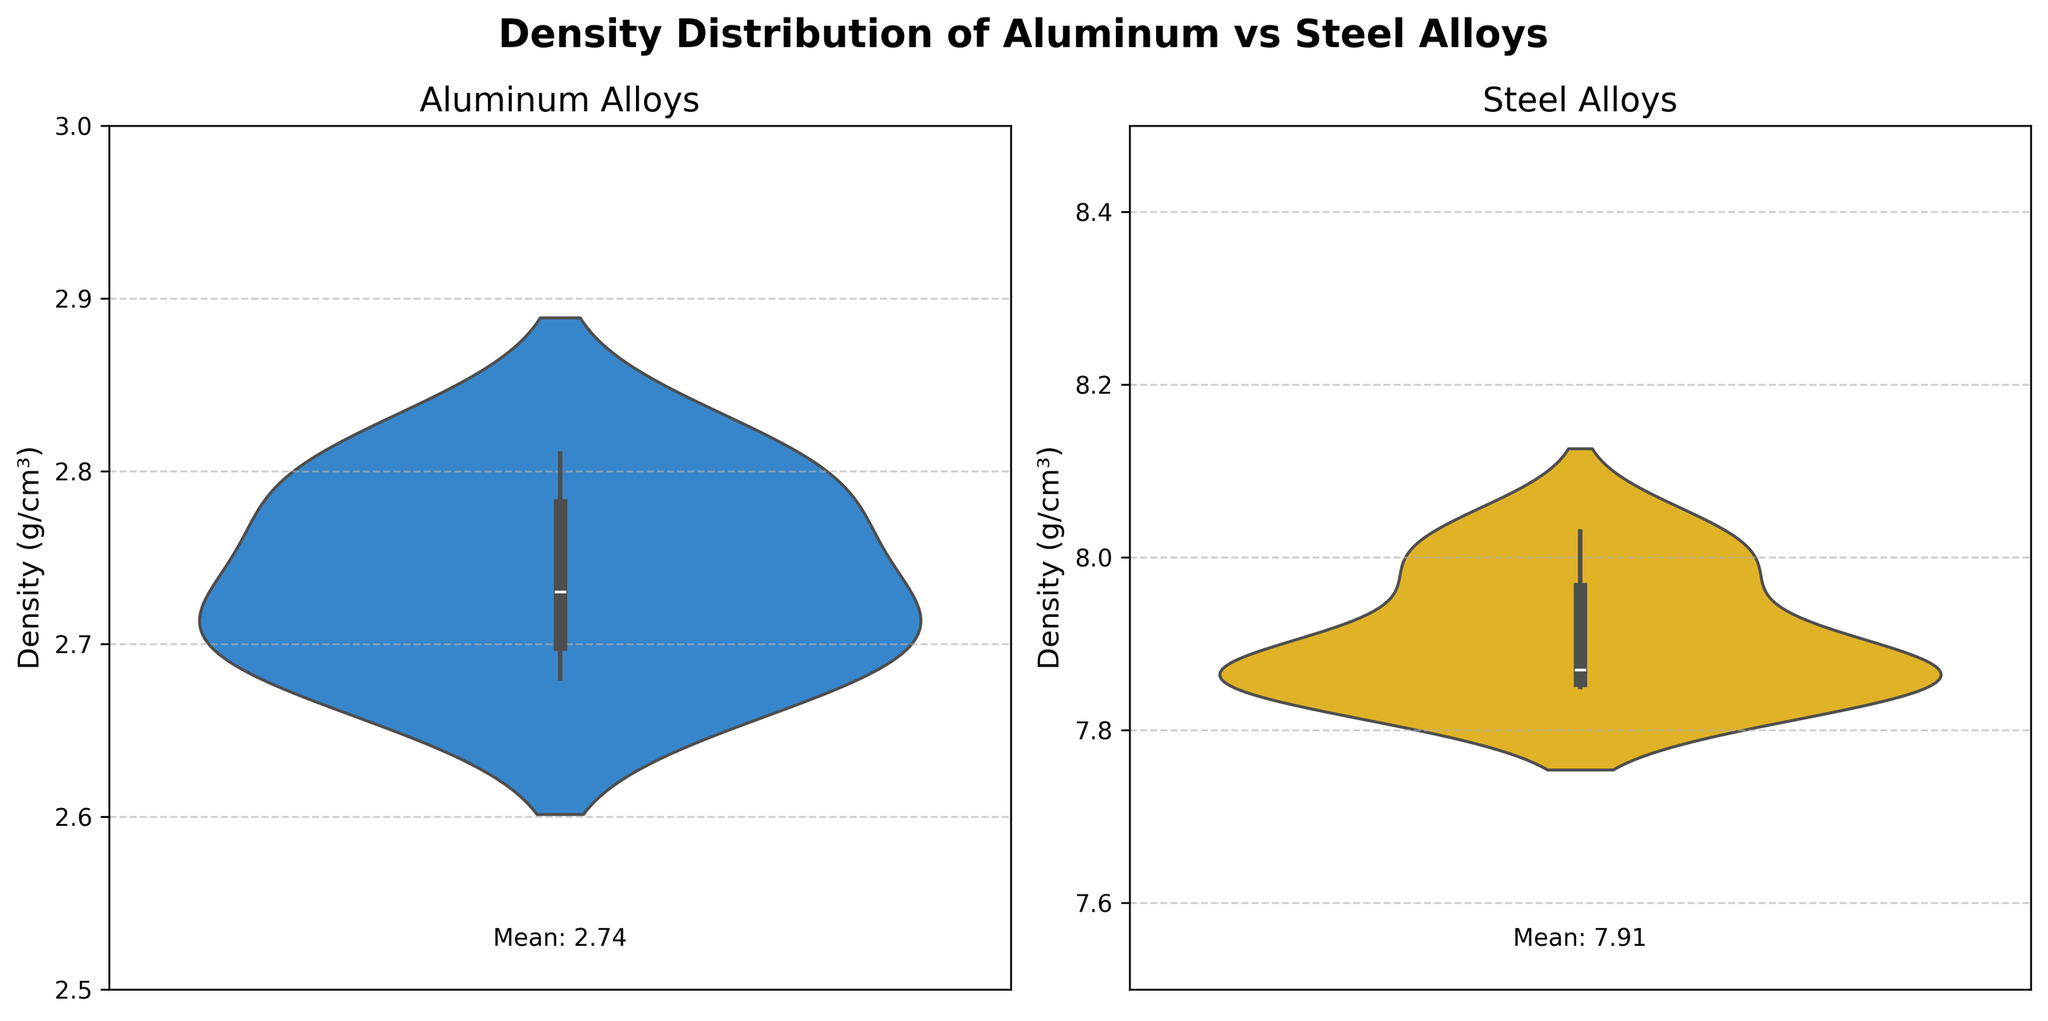What is the title of the figure? The title is usually displayed at the top of the figure and often summarizes the content of the plot. In this case, it can be found at the very top of the subplot.
Answer: Density Distribution of Aluminum vs Steel Alloys What are the colors used for the aluminum and steel violin plots? The colors of the violin plots help to visually distinguish between the two materials. The aluminum violin plot is blue, and the steel violin plot is yellow.
Answer: Blue and Yellow What is the mean density value of the aluminum alloys? The mean density value is annotated at the bottom of the aluminum subplot in the figure. It reads "Mean: 2.74".
Answer: 2.74 What is the mean density value of the steel alloys? The mean density value is given at the bottom of the steel subplot in the figure. It reads "Mean: 7.91".
Answer: 7.91 How do the densities of aluminum and steel alloys compare on average? From the annotated mean density values, we can see that the average density of steel alloys is significantly higher than that of aluminum alloys.
Answer: Steel alloys have a higher average density than aluminum alloys Which plot has a wider distribution of density values, aluminum or steel? By examining the spread of the violin plots, the steel plot shows a wider distribution spread from 7.85 to above 8.00, whereas the aluminum plot is more compact between 2.68 and 2.81.
Answer: Steel Which material type shows a greater range in density values? The range can be observed by looking at the vertical spread of the violin plots. Steel alloys range from 7.85 to 8.03, whereas aluminum ranges from 2.68 to 2.81.
Answer: Steel What's the maximum density value for the steel alloys? The maximum value is observed at the top of the steel violin plot, which is about 8.03.
Answer: 8.03 What is the difference between the maximum densities of steel and aluminum alloys? The maximum density of steel is 8.03 and aluminum is 2.81. The difference is calculated as 8.03 - 2.81.
Answer: 5.22 Can you identify any outliers in either the aluminum or steel distributions? The violin plots include box plots to show interquartile ranges and potential outliers; however, none are apparent in this figure.
Answer: No visible outliers 